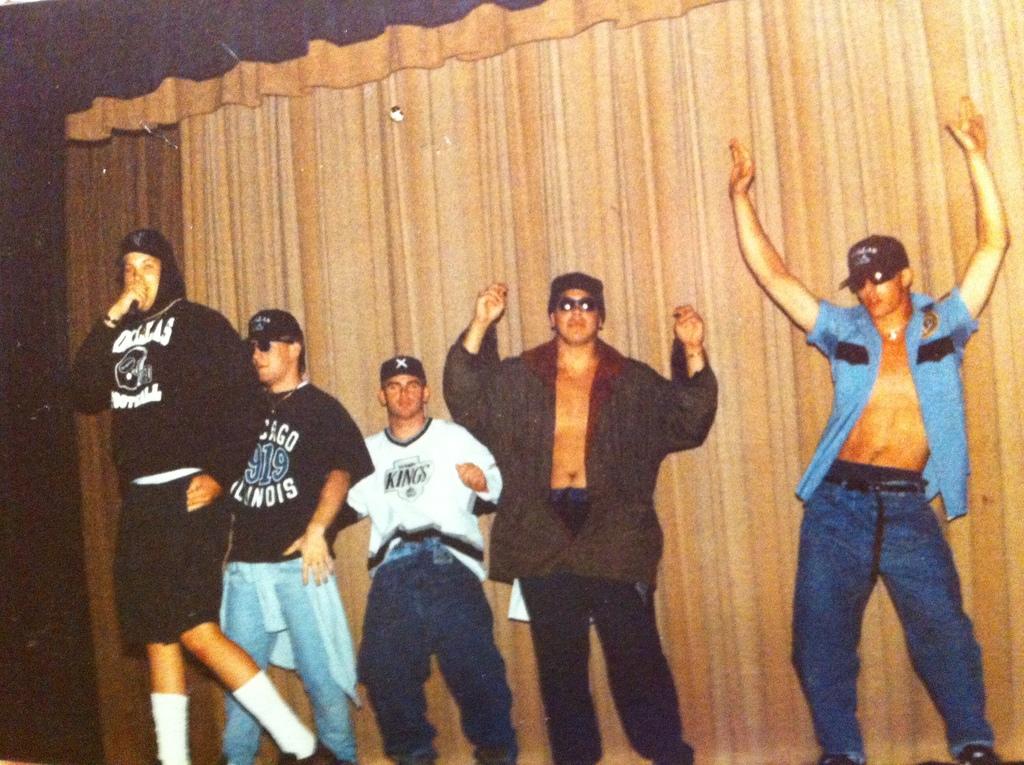What team is the third guy representing?
Make the answer very short. Kings. 